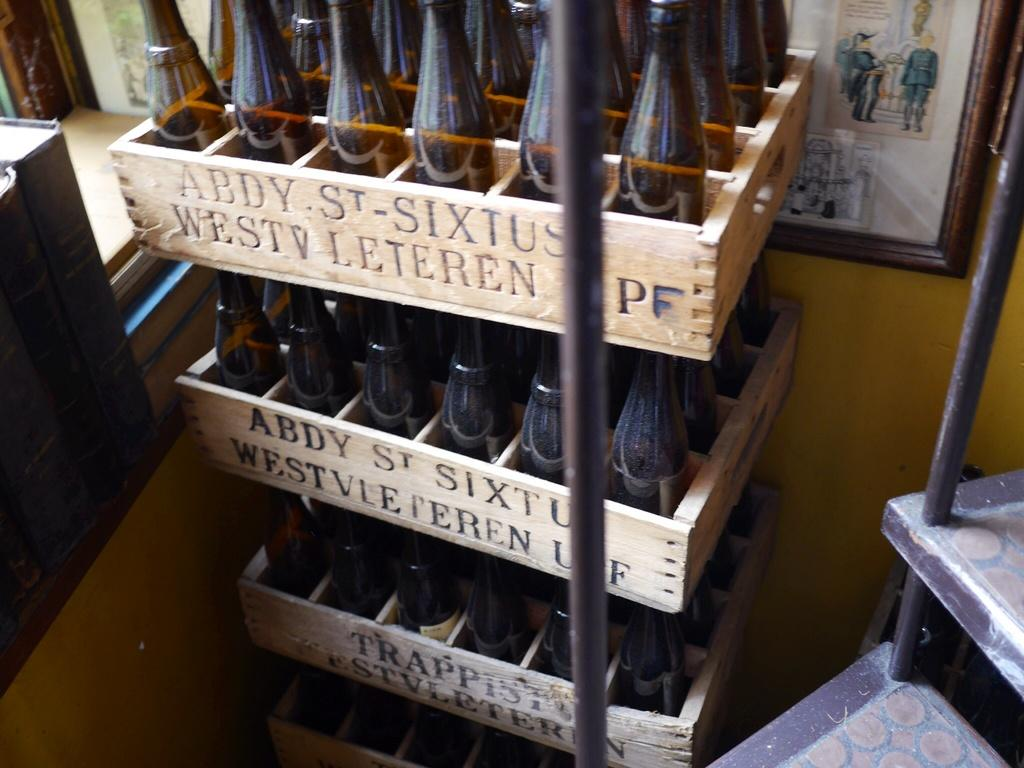<image>
Provide a brief description of the given image. A stack of crates that say Abdy St Sixtus Westv Leteren have brown bottles in them. 